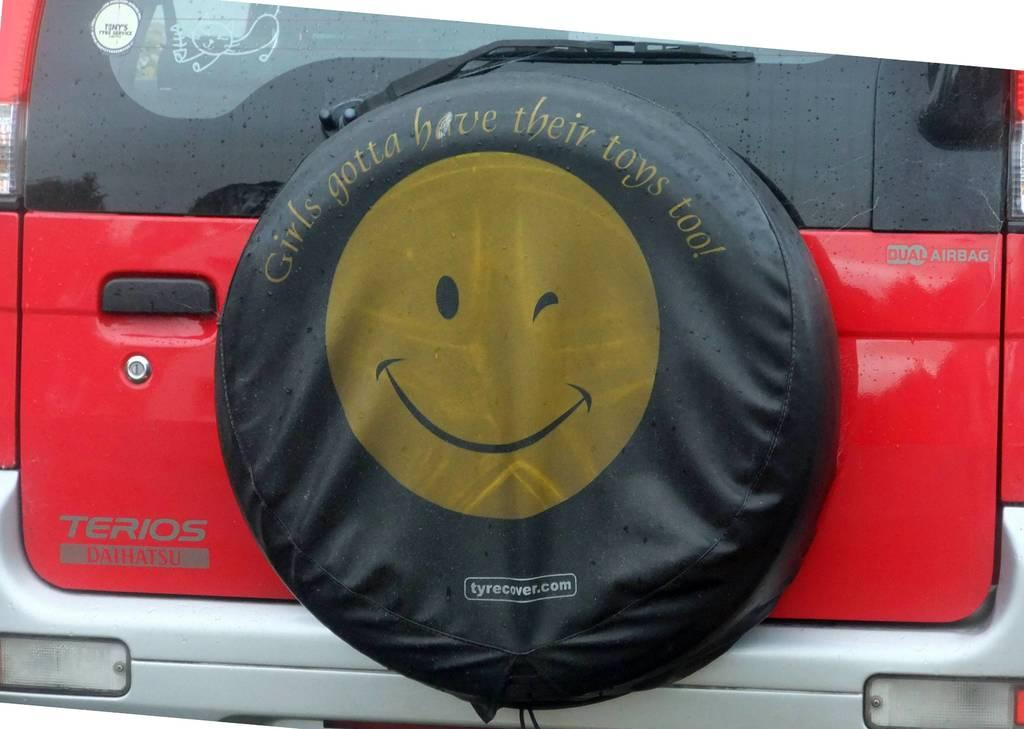What type of vehicle is in the picture? There is a red color car in the picture. What shape can be seen in the picture besides the car? There is a circular object in the picture. What is on the circular object? The circular object has a symbol on it. How can the car door be opened? The car door has a handle. What is used to clean the car's windshield in the picture? There is a glass wiper in the picture. What type of brain is visible in the picture? There is no brain visible in the picture; it features a red color car, a circular object, a symbol, a car door handle, and a glass wiper. 